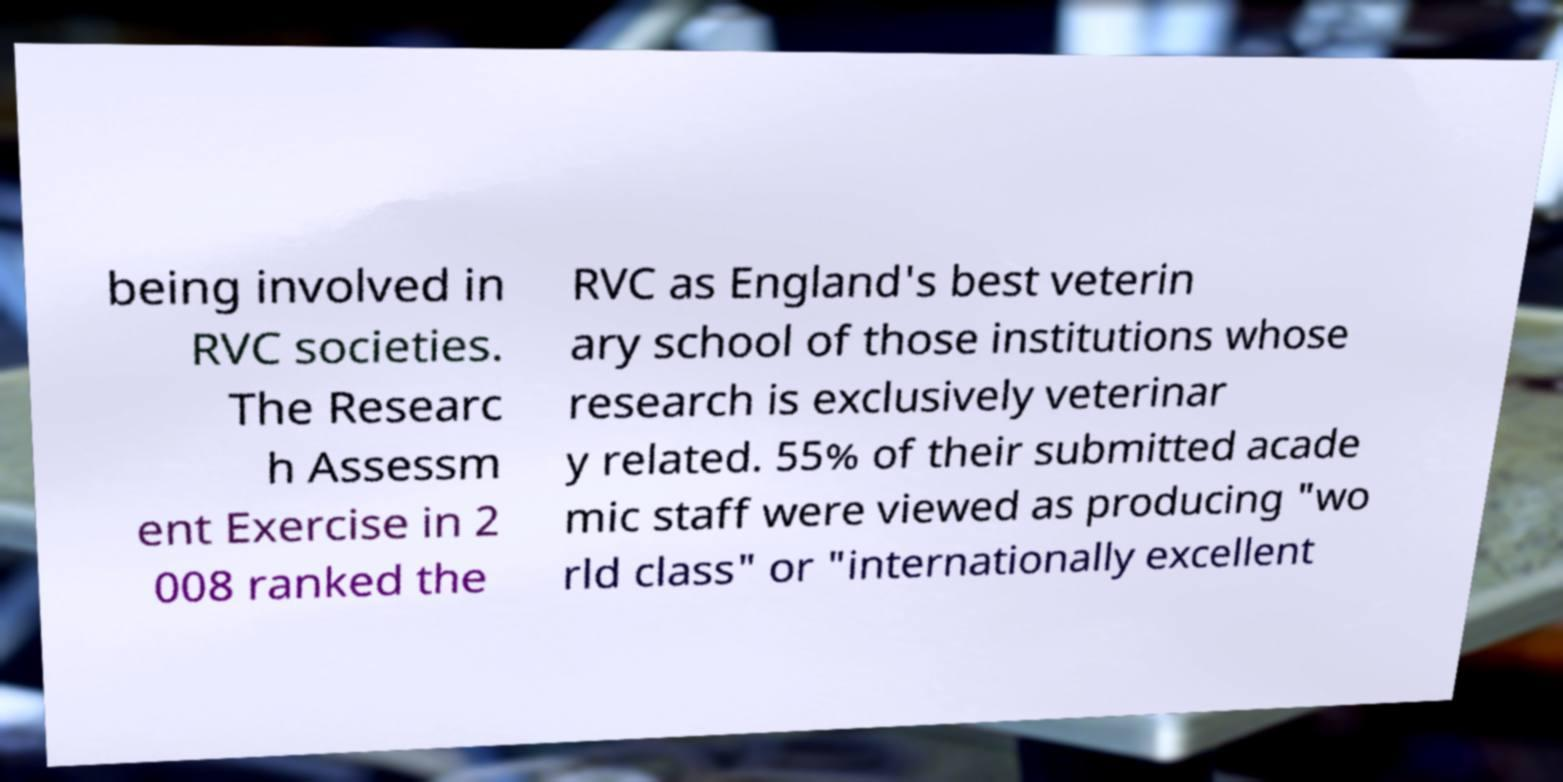Can you accurately transcribe the text from the provided image for me? being involved in RVC societies. The Researc h Assessm ent Exercise in 2 008 ranked the RVC as England's best veterin ary school of those institutions whose research is exclusively veterinar y related. 55% of their submitted acade mic staff were viewed as producing "wo rld class" or "internationally excellent 